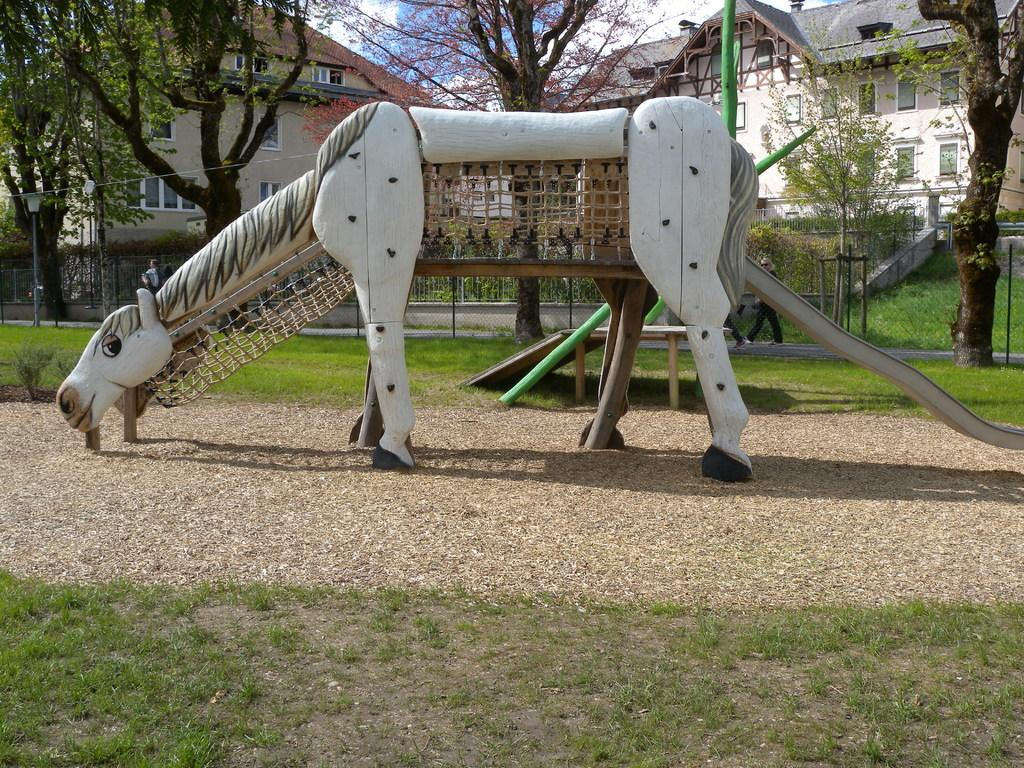What type of slide is featured in the image? The slide in the image is in the shape of an animal. What can be seen in the background of the image? Trees, buildings, windows, a light pole, fencing, and people walking on the road are visible in the background of the image. What type of riddle is written on the slide in the image? There is no riddle written on the slide in the image; it is a slide in the shape of an animal. Can you tell me the emotional state of the heart in the image? There is no heart present in the image; it features a slide and various background elements. 